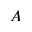<formula> <loc_0><loc_0><loc_500><loc_500>A</formula> 